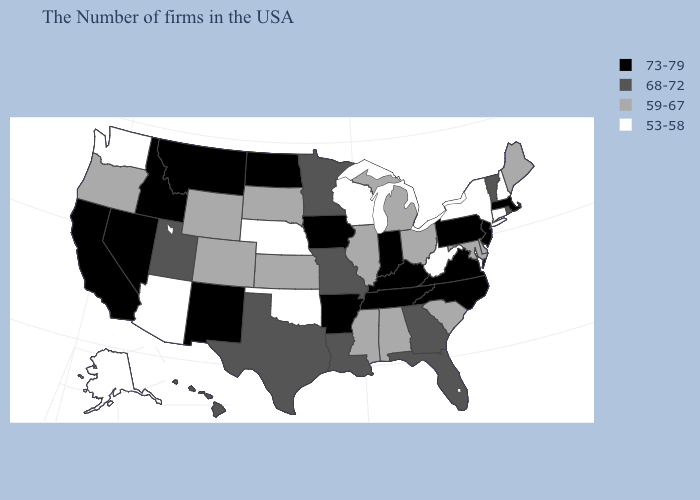What is the value of Kansas?
Be succinct. 59-67. Is the legend a continuous bar?
Keep it brief. No. What is the highest value in the West ?
Keep it brief. 73-79. Among the states that border Indiana , does Michigan have the lowest value?
Answer briefly. Yes. What is the value of Vermont?
Keep it brief. 68-72. Which states have the lowest value in the USA?
Be succinct. New Hampshire, Connecticut, New York, West Virginia, Wisconsin, Nebraska, Oklahoma, Arizona, Washington, Alaska. What is the value of New Mexico?
Concise answer only. 73-79. Does Montana have the lowest value in the USA?
Keep it brief. No. Which states hav the highest value in the South?
Answer briefly. Virginia, North Carolina, Kentucky, Tennessee, Arkansas. Does the map have missing data?
Answer briefly. No. What is the highest value in the USA?
Concise answer only. 73-79. Does Wisconsin have the lowest value in the MidWest?
Concise answer only. Yes. Among the states that border Nevada , does Utah have the lowest value?
Give a very brief answer. No. What is the lowest value in the MidWest?
Short answer required. 53-58. Among the states that border Virginia , does Tennessee have the lowest value?
Write a very short answer. No. 